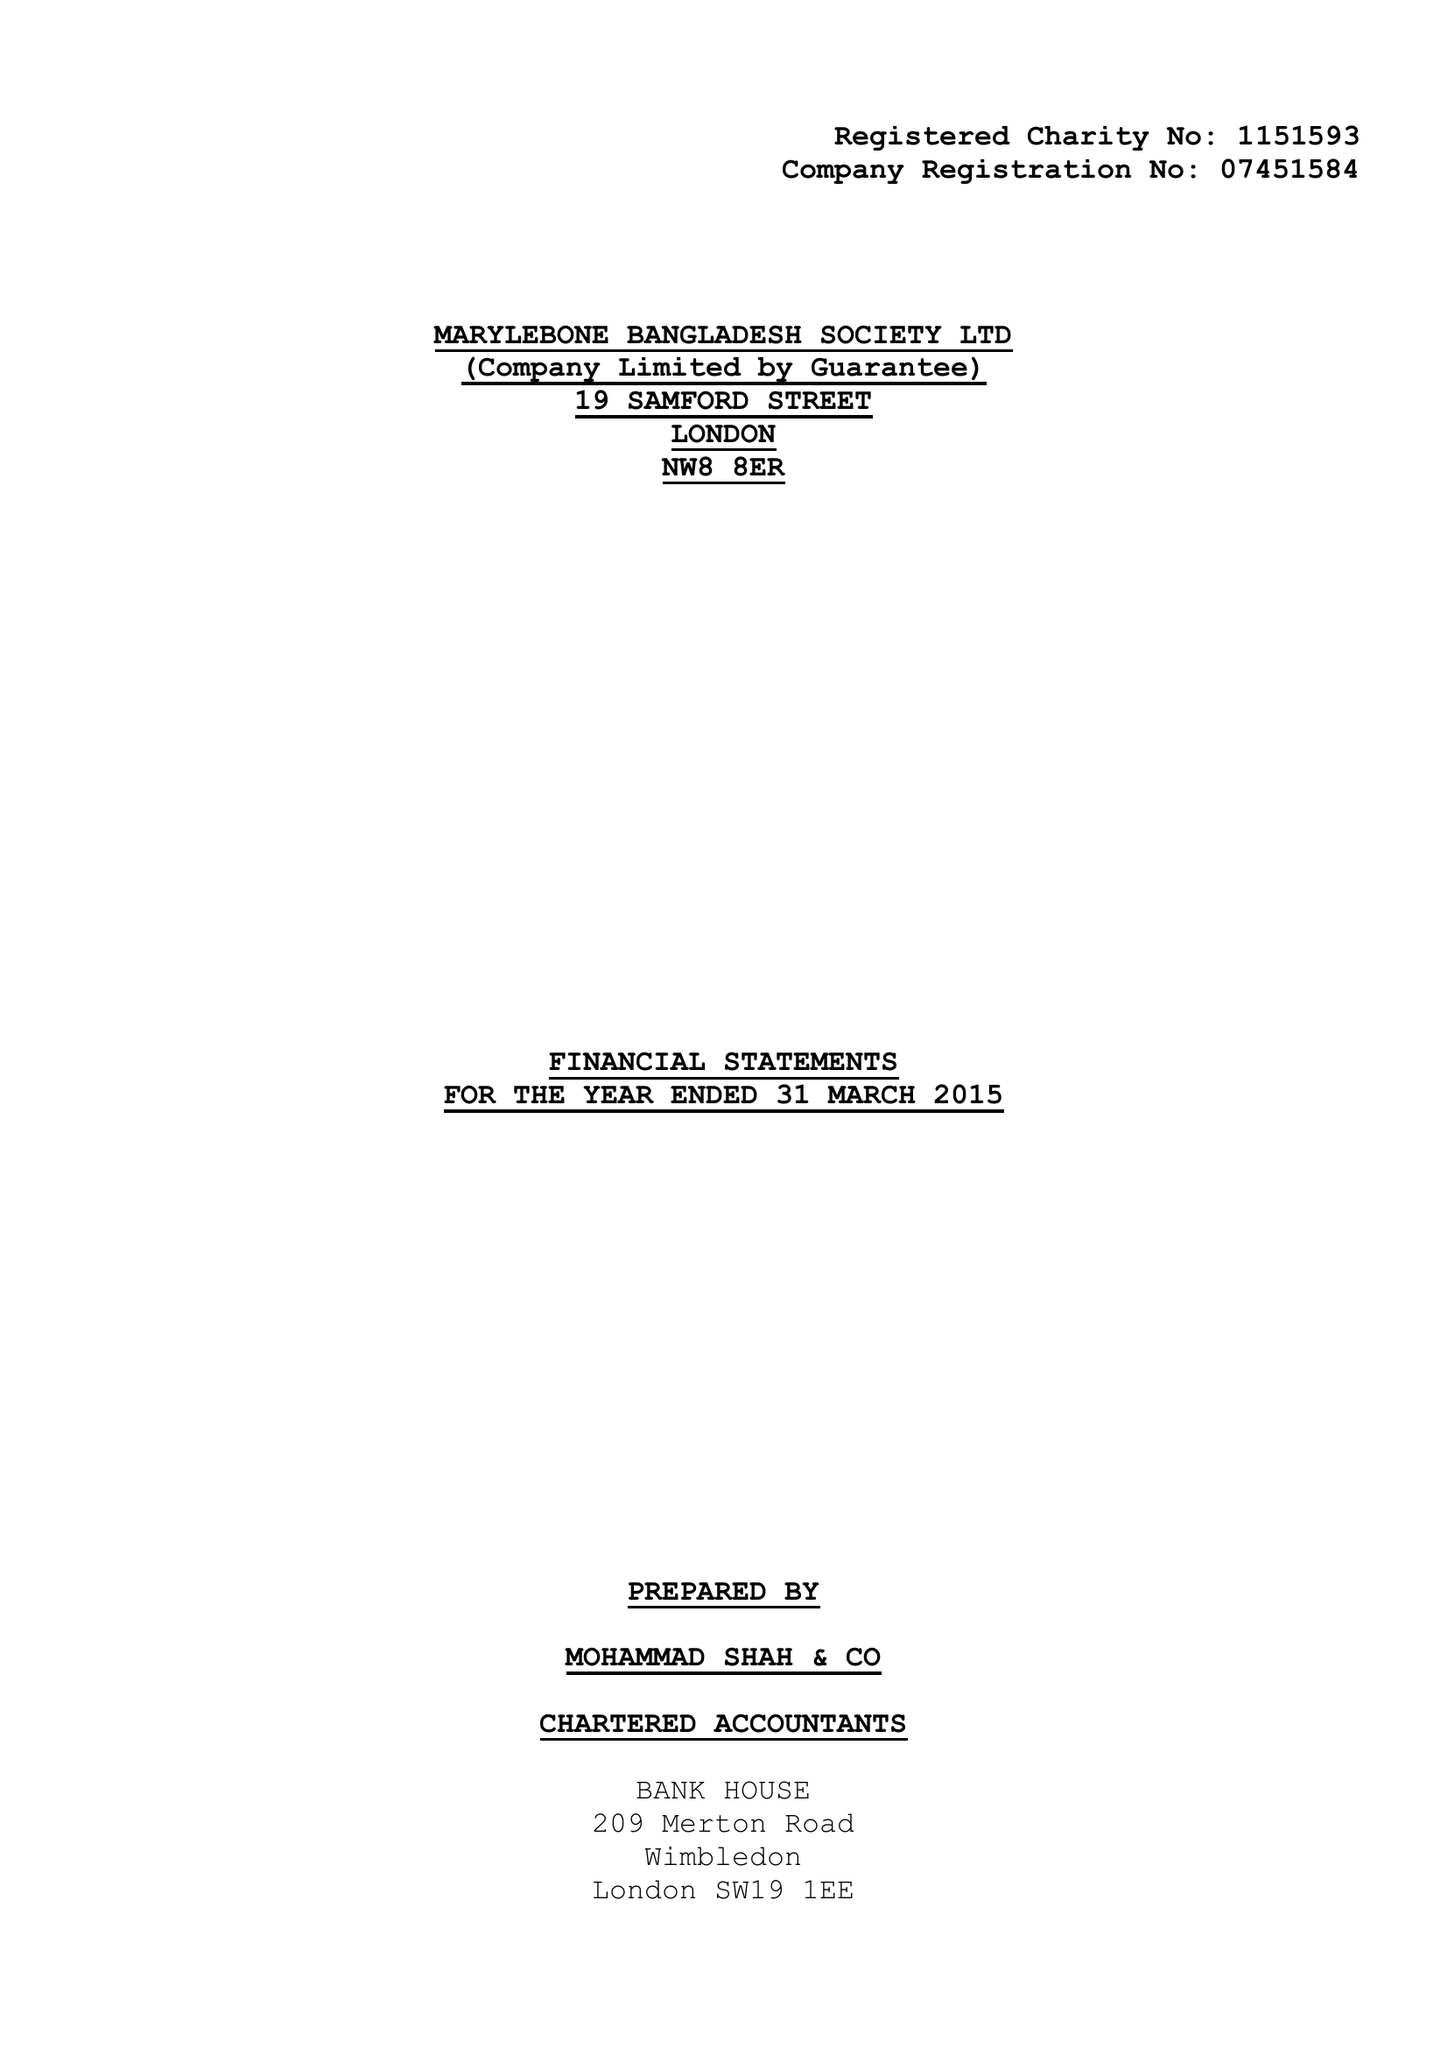What is the value for the charity_name?
Answer the question using a single word or phrase. Marylebone Bangladesh Society Ltd. 